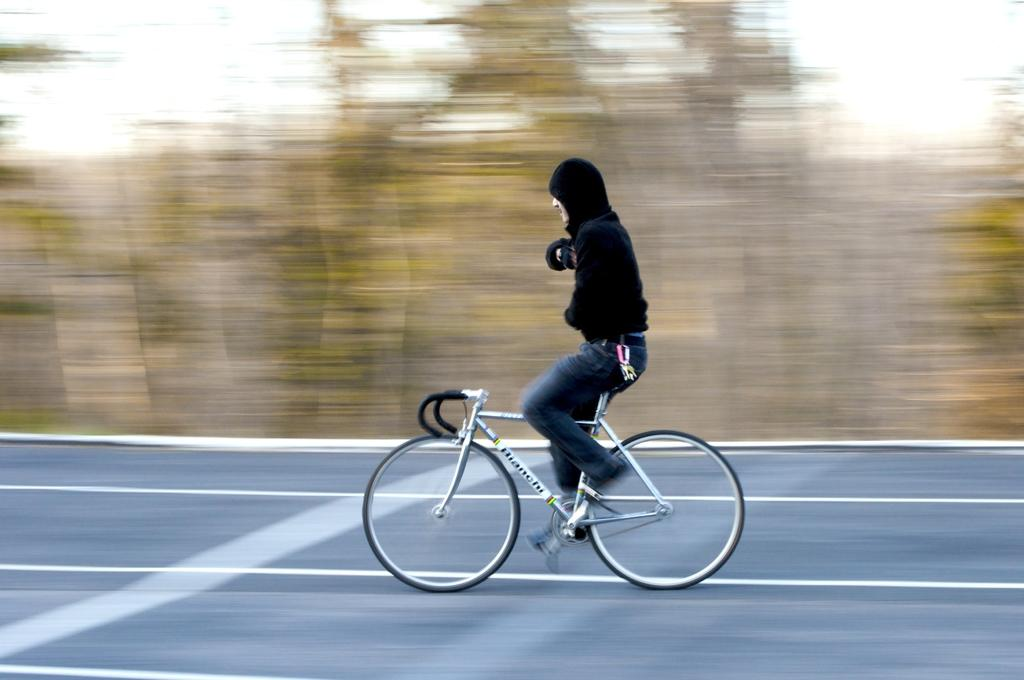What is the person in the image doing? The person is riding a bicycle. Where is the bicycle located in the image? The bicycle is on the road. What can be seen in the background of the image? There are trees and the sky visible in the background of the image. How does the person tie a knot while riding the bicycle in the image? There is no knot-tying activity depicted in the image; the person is simply riding a bicycle on the road. 